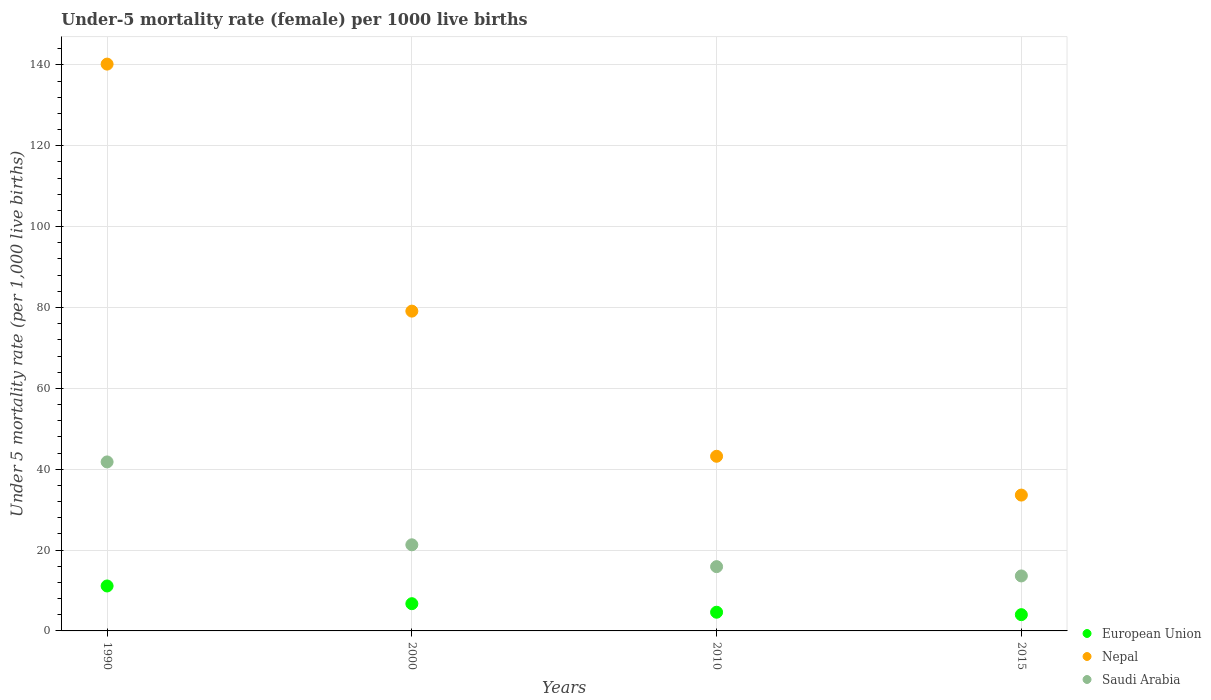How many different coloured dotlines are there?
Offer a terse response. 3. What is the under-five mortality rate in Nepal in 2010?
Provide a short and direct response. 43.2. Across all years, what is the maximum under-five mortality rate in Nepal?
Offer a terse response. 140.2. In which year was the under-five mortality rate in Saudi Arabia maximum?
Your answer should be compact. 1990. In which year was the under-five mortality rate in Saudi Arabia minimum?
Provide a short and direct response. 2015. What is the total under-five mortality rate in Nepal in the graph?
Provide a short and direct response. 296.1. What is the difference between the under-five mortality rate in Nepal in 2000 and that in 2015?
Offer a terse response. 45.5. What is the difference between the under-five mortality rate in Nepal in 2015 and the under-five mortality rate in European Union in 2000?
Your answer should be very brief. 26.87. What is the average under-five mortality rate in European Union per year?
Offer a terse response. 6.62. In the year 2015, what is the difference between the under-five mortality rate in Nepal and under-five mortality rate in Saudi Arabia?
Offer a very short reply. 20. In how many years, is the under-five mortality rate in Nepal greater than 124?
Make the answer very short. 1. What is the ratio of the under-five mortality rate in Nepal in 1990 to that in 2010?
Your answer should be very brief. 3.25. What is the difference between the highest and the second highest under-five mortality rate in Nepal?
Provide a short and direct response. 61.1. What is the difference between the highest and the lowest under-five mortality rate in Saudi Arabia?
Give a very brief answer. 28.2. In how many years, is the under-five mortality rate in European Union greater than the average under-five mortality rate in European Union taken over all years?
Ensure brevity in your answer.  2. Is the sum of the under-five mortality rate in European Union in 2000 and 2015 greater than the maximum under-five mortality rate in Saudi Arabia across all years?
Your answer should be compact. No. Does the under-five mortality rate in Saudi Arabia monotonically increase over the years?
Provide a succinct answer. No. Is the under-five mortality rate in European Union strictly greater than the under-five mortality rate in Saudi Arabia over the years?
Your response must be concise. No. Is the under-five mortality rate in Nepal strictly less than the under-five mortality rate in European Union over the years?
Ensure brevity in your answer.  No. How many years are there in the graph?
Give a very brief answer. 4. Does the graph contain any zero values?
Offer a very short reply. No. Where does the legend appear in the graph?
Your response must be concise. Bottom right. How many legend labels are there?
Keep it short and to the point. 3. What is the title of the graph?
Provide a short and direct response. Under-5 mortality rate (female) per 1000 live births. What is the label or title of the Y-axis?
Your response must be concise. Under 5 mortality rate (per 1,0 live births). What is the Under 5 mortality rate (per 1,000 live births) in European Union in 1990?
Provide a short and direct response. 11.12. What is the Under 5 mortality rate (per 1,000 live births) of Nepal in 1990?
Give a very brief answer. 140.2. What is the Under 5 mortality rate (per 1,000 live births) of Saudi Arabia in 1990?
Offer a very short reply. 41.8. What is the Under 5 mortality rate (per 1,000 live births) of European Union in 2000?
Keep it short and to the point. 6.73. What is the Under 5 mortality rate (per 1,000 live births) of Nepal in 2000?
Your response must be concise. 79.1. What is the Under 5 mortality rate (per 1,000 live births) of Saudi Arabia in 2000?
Give a very brief answer. 21.3. What is the Under 5 mortality rate (per 1,000 live births) of European Union in 2010?
Offer a very short reply. 4.62. What is the Under 5 mortality rate (per 1,000 live births) of Nepal in 2010?
Ensure brevity in your answer.  43.2. What is the Under 5 mortality rate (per 1,000 live births) in Saudi Arabia in 2010?
Provide a succinct answer. 15.9. What is the Under 5 mortality rate (per 1,000 live births) in European Union in 2015?
Provide a succinct answer. 4.02. What is the Under 5 mortality rate (per 1,000 live births) of Nepal in 2015?
Provide a succinct answer. 33.6. Across all years, what is the maximum Under 5 mortality rate (per 1,000 live births) in European Union?
Your response must be concise. 11.12. Across all years, what is the maximum Under 5 mortality rate (per 1,000 live births) of Nepal?
Ensure brevity in your answer.  140.2. Across all years, what is the maximum Under 5 mortality rate (per 1,000 live births) of Saudi Arabia?
Your answer should be very brief. 41.8. Across all years, what is the minimum Under 5 mortality rate (per 1,000 live births) of European Union?
Provide a succinct answer. 4.02. Across all years, what is the minimum Under 5 mortality rate (per 1,000 live births) of Nepal?
Make the answer very short. 33.6. What is the total Under 5 mortality rate (per 1,000 live births) of European Union in the graph?
Offer a very short reply. 26.5. What is the total Under 5 mortality rate (per 1,000 live births) of Nepal in the graph?
Your answer should be very brief. 296.1. What is the total Under 5 mortality rate (per 1,000 live births) of Saudi Arabia in the graph?
Your answer should be compact. 92.6. What is the difference between the Under 5 mortality rate (per 1,000 live births) of European Union in 1990 and that in 2000?
Keep it short and to the point. 4.38. What is the difference between the Under 5 mortality rate (per 1,000 live births) of Nepal in 1990 and that in 2000?
Your response must be concise. 61.1. What is the difference between the Under 5 mortality rate (per 1,000 live births) in Saudi Arabia in 1990 and that in 2000?
Your response must be concise. 20.5. What is the difference between the Under 5 mortality rate (per 1,000 live births) of European Union in 1990 and that in 2010?
Provide a succinct answer. 6.49. What is the difference between the Under 5 mortality rate (per 1,000 live births) of Nepal in 1990 and that in 2010?
Your answer should be very brief. 97. What is the difference between the Under 5 mortality rate (per 1,000 live births) of Saudi Arabia in 1990 and that in 2010?
Your answer should be very brief. 25.9. What is the difference between the Under 5 mortality rate (per 1,000 live births) in European Union in 1990 and that in 2015?
Provide a succinct answer. 7.1. What is the difference between the Under 5 mortality rate (per 1,000 live births) in Nepal in 1990 and that in 2015?
Provide a succinct answer. 106.6. What is the difference between the Under 5 mortality rate (per 1,000 live births) in Saudi Arabia in 1990 and that in 2015?
Provide a succinct answer. 28.2. What is the difference between the Under 5 mortality rate (per 1,000 live births) in European Union in 2000 and that in 2010?
Offer a very short reply. 2.11. What is the difference between the Under 5 mortality rate (per 1,000 live births) in Nepal in 2000 and that in 2010?
Offer a very short reply. 35.9. What is the difference between the Under 5 mortality rate (per 1,000 live births) in European Union in 2000 and that in 2015?
Keep it short and to the point. 2.71. What is the difference between the Under 5 mortality rate (per 1,000 live births) of Nepal in 2000 and that in 2015?
Your response must be concise. 45.5. What is the difference between the Under 5 mortality rate (per 1,000 live births) in Saudi Arabia in 2000 and that in 2015?
Your response must be concise. 7.7. What is the difference between the Under 5 mortality rate (per 1,000 live births) of European Union in 2010 and that in 2015?
Keep it short and to the point. 0.6. What is the difference between the Under 5 mortality rate (per 1,000 live births) in Nepal in 2010 and that in 2015?
Give a very brief answer. 9.6. What is the difference between the Under 5 mortality rate (per 1,000 live births) of European Union in 1990 and the Under 5 mortality rate (per 1,000 live births) of Nepal in 2000?
Offer a very short reply. -67.98. What is the difference between the Under 5 mortality rate (per 1,000 live births) in European Union in 1990 and the Under 5 mortality rate (per 1,000 live births) in Saudi Arabia in 2000?
Provide a short and direct response. -10.18. What is the difference between the Under 5 mortality rate (per 1,000 live births) in Nepal in 1990 and the Under 5 mortality rate (per 1,000 live births) in Saudi Arabia in 2000?
Give a very brief answer. 118.9. What is the difference between the Under 5 mortality rate (per 1,000 live births) of European Union in 1990 and the Under 5 mortality rate (per 1,000 live births) of Nepal in 2010?
Offer a very short reply. -32.08. What is the difference between the Under 5 mortality rate (per 1,000 live births) of European Union in 1990 and the Under 5 mortality rate (per 1,000 live births) of Saudi Arabia in 2010?
Give a very brief answer. -4.78. What is the difference between the Under 5 mortality rate (per 1,000 live births) of Nepal in 1990 and the Under 5 mortality rate (per 1,000 live births) of Saudi Arabia in 2010?
Offer a very short reply. 124.3. What is the difference between the Under 5 mortality rate (per 1,000 live births) of European Union in 1990 and the Under 5 mortality rate (per 1,000 live births) of Nepal in 2015?
Keep it short and to the point. -22.48. What is the difference between the Under 5 mortality rate (per 1,000 live births) of European Union in 1990 and the Under 5 mortality rate (per 1,000 live births) of Saudi Arabia in 2015?
Your response must be concise. -2.48. What is the difference between the Under 5 mortality rate (per 1,000 live births) of Nepal in 1990 and the Under 5 mortality rate (per 1,000 live births) of Saudi Arabia in 2015?
Ensure brevity in your answer.  126.6. What is the difference between the Under 5 mortality rate (per 1,000 live births) of European Union in 2000 and the Under 5 mortality rate (per 1,000 live births) of Nepal in 2010?
Offer a terse response. -36.47. What is the difference between the Under 5 mortality rate (per 1,000 live births) of European Union in 2000 and the Under 5 mortality rate (per 1,000 live births) of Saudi Arabia in 2010?
Provide a succinct answer. -9.17. What is the difference between the Under 5 mortality rate (per 1,000 live births) in Nepal in 2000 and the Under 5 mortality rate (per 1,000 live births) in Saudi Arabia in 2010?
Your answer should be compact. 63.2. What is the difference between the Under 5 mortality rate (per 1,000 live births) in European Union in 2000 and the Under 5 mortality rate (per 1,000 live births) in Nepal in 2015?
Make the answer very short. -26.87. What is the difference between the Under 5 mortality rate (per 1,000 live births) of European Union in 2000 and the Under 5 mortality rate (per 1,000 live births) of Saudi Arabia in 2015?
Provide a short and direct response. -6.87. What is the difference between the Under 5 mortality rate (per 1,000 live births) of Nepal in 2000 and the Under 5 mortality rate (per 1,000 live births) of Saudi Arabia in 2015?
Make the answer very short. 65.5. What is the difference between the Under 5 mortality rate (per 1,000 live births) in European Union in 2010 and the Under 5 mortality rate (per 1,000 live births) in Nepal in 2015?
Ensure brevity in your answer.  -28.98. What is the difference between the Under 5 mortality rate (per 1,000 live births) in European Union in 2010 and the Under 5 mortality rate (per 1,000 live births) in Saudi Arabia in 2015?
Make the answer very short. -8.98. What is the difference between the Under 5 mortality rate (per 1,000 live births) in Nepal in 2010 and the Under 5 mortality rate (per 1,000 live births) in Saudi Arabia in 2015?
Keep it short and to the point. 29.6. What is the average Under 5 mortality rate (per 1,000 live births) in European Union per year?
Provide a succinct answer. 6.62. What is the average Under 5 mortality rate (per 1,000 live births) in Nepal per year?
Give a very brief answer. 74.03. What is the average Under 5 mortality rate (per 1,000 live births) of Saudi Arabia per year?
Offer a terse response. 23.15. In the year 1990, what is the difference between the Under 5 mortality rate (per 1,000 live births) of European Union and Under 5 mortality rate (per 1,000 live births) of Nepal?
Make the answer very short. -129.08. In the year 1990, what is the difference between the Under 5 mortality rate (per 1,000 live births) in European Union and Under 5 mortality rate (per 1,000 live births) in Saudi Arabia?
Make the answer very short. -30.68. In the year 1990, what is the difference between the Under 5 mortality rate (per 1,000 live births) in Nepal and Under 5 mortality rate (per 1,000 live births) in Saudi Arabia?
Offer a very short reply. 98.4. In the year 2000, what is the difference between the Under 5 mortality rate (per 1,000 live births) of European Union and Under 5 mortality rate (per 1,000 live births) of Nepal?
Keep it short and to the point. -72.37. In the year 2000, what is the difference between the Under 5 mortality rate (per 1,000 live births) in European Union and Under 5 mortality rate (per 1,000 live births) in Saudi Arabia?
Provide a succinct answer. -14.57. In the year 2000, what is the difference between the Under 5 mortality rate (per 1,000 live births) of Nepal and Under 5 mortality rate (per 1,000 live births) of Saudi Arabia?
Provide a succinct answer. 57.8. In the year 2010, what is the difference between the Under 5 mortality rate (per 1,000 live births) in European Union and Under 5 mortality rate (per 1,000 live births) in Nepal?
Offer a very short reply. -38.58. In the year 2010, what is the difference between the Under 5 mortality rate (per 1,000 live births) in European Union and Under 5 mortality rate (per 1,000 live births) in Saudi Arabia?
Your answer should be very brief. -11.28. In the year 2010, what is the difference between the Under 5 mortality rate (per 1,000 live births) in Nepal and Under 5 mortality rate (per 1,000 live births) in Saudi Arabia?
Keep it short and to the point. 27.3. In the year 2015, what is the difference between the Under 5 mortality rate (per 1,000 live births) of European Union and Under 5 mortality rate (per 1,000 live births) of Nepal?
Your response must be concise. -29.58. In the year 2015, what is the difference between the Under 5 mortality rate (per 1,000 live births) of European Union and Under 5 mortality rate (per 1,000 live births) of Saudi Arabia?
Give a very brief answer. -9.58. What is the ratio of the Under 5 mortality rate (per 1,000 live births) in European Union in 1990 to that in 2000?
Your response must be concise. 1.65. What is the ratio of the Under 5 mortality rate (per 1,000 live births) of Nepal in 1990 to that in 2000?
Keep it short and to the point. 1.77. What is the ratio of the Under 5 mortality rate (per 1,000 live births) of Saudi Arabia in 1990 to that in 2000?
Offer a terse response. 1.96. What is the ratio of the Under 5 mortality rate (per 1,000 live births) of European Union in 1990 to that in 2010?
Ensure brevity in your answer.  2.4. What is the ratio of the Under 5 mortality rate (per 1,000 live births) of Nepal in 1990 to that in 2010?
Offer a terse response. 3.25. What is the ratio of the Under 5 mortality rate (per 1,000 live births) of Saudi Arabia in 1990 to that in 2010?
Offer a very short reply. 2.63. What is the ratio of the Under 5 mortality rate (per 1,000 live births) in European Union in 1990 to that in 2015?
Keep it short and to the point. 2.76. What is the ratio of the Under 5 mortality rate (per 1,000 live births) of Nepal in 1990 to that in 2015?
Offer a very short reply. 4.17. What is the ratio of the Under 5 mortality rate (per 1,000 live births) of Saudi Arabia in 1990 to that in 2015?
Make the answer very short. 3.07. What is the ratio of the Under 5 mortality rate (per 1,000 live births) in European Union in 2000 to that in 2010?
Offer a very short reply. 1.46. What is the ratio of the Under 5 mortality rate (per 1,000 live births) in Nepal in 2000 to that in 2010?
Provide a succinct answer. 1.83. What is the ratio of the Under 5 mortality rate (per 1,000 live births) in Saudi Arabia in 2000 to that in 2010?
Make the answer very short. 1.34. What is the ratio of the Under 5 mortality rate (per 1,000 live births) of European Union in 2000 to that in 2015?
Your answer should be compact. 1.67. What is the ratio of the Under 5 mortality rate (per 1,000 live births) of Nepal in 2000 to that in 2015?
Keep it short and to the point. 2.35. What is the ratio of the Under 5 mortality rate (per 1,000 live births) of Saudi Arabia in 2000 to that in 2015?
Your response must be concise. 1.57. What is the ratio of the Under 5 mortality rate (per 1,000 live births) in European Union in 2010 to that in 2015?
Provide a succinct answer. 1.15. What is the ratio of the Under 5 mortality rate (per 1,000 live births) of Saudi Arabia in 2010 to that in 2015?
Make the answer very short. 1.17. What is the difference between the highest and the second highest Under 5 mortality rate (per 1,000 live births) in European Union?
Ensure brevity in your answer.  4.38. What is the difference between the highest and the second highest Under 5 mortality rate (per 1,000 live births) in Nepal?
Your answer should be compact. 61.1. What is the difference between the highest and the lowest Under 5 mortality rate (per 1,000 live births) of European Union?
Make the answer very short. 7.1. What is the difference between the highest and the lowest Under 5 mortality rate (per 1,000 live births) of Nepal?
Ensure brevity in your answer.  106.6. What is the difference between the highest and the lowest Under 5 mortality rate (per 1,000 live births) in Saudi Arabia?
Provide a succinct answer. 28.2. 